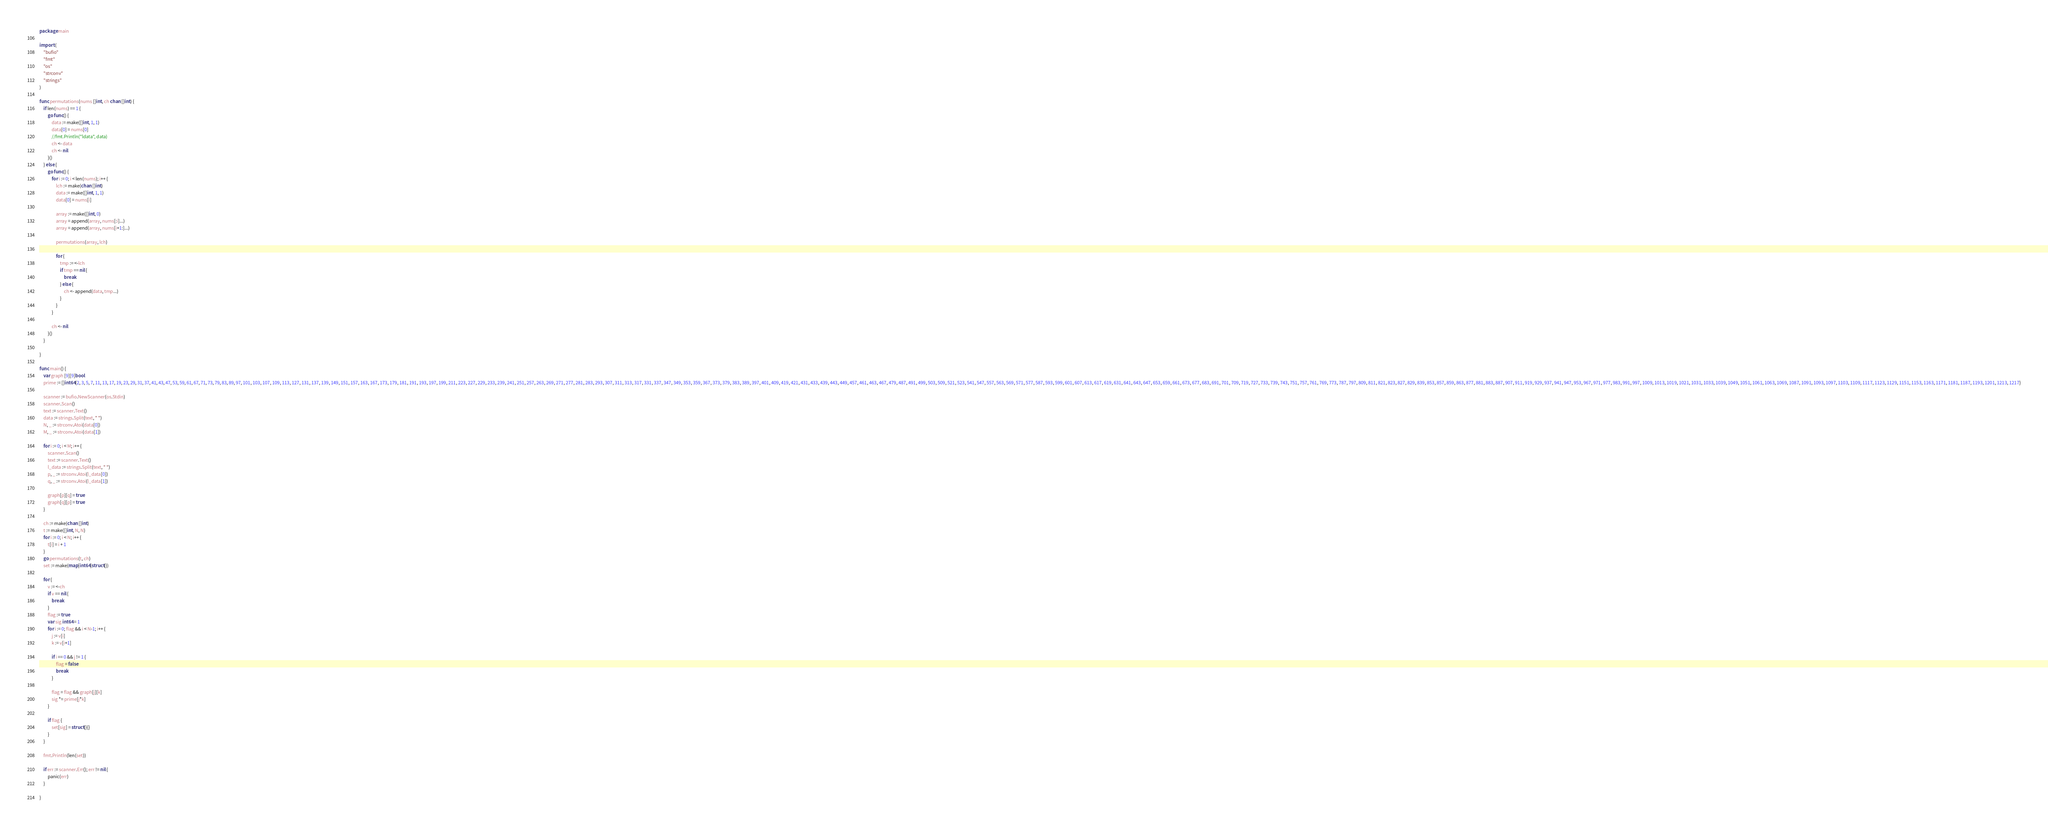<code> <loc_0><loc_0><loc_500><loc_500><_Go_>package main

import (
	"bufio"
	"fmt"
	"os"
	"strconv"
	"strings"
)

func permutations(nums []int, ch chan []int) {
	if len(nums) == 1 {
		go func() {
			data := make([]int, 1, 1)
			data[0] = nums[0]
			//fmt.Println("ldata", data)
			ch <- data
			ch <- nil
		}()
	} else {
		go func() {
			for i := 0; i < len(nums); i++ {
				lch := make(chan []int)
				data := make([]int, 1, 1)
				data[0] = nums[i]

				array := make([]int, 0)
				array = append(array, nums[:i]...)
				array = append(array, nums[i+1:]...)

				permutations(array, lch)

				for {
					tmp := <-lch
					if tmp == nil {
						break
					} else {
						ch <- append(data, tmp...)
					}
				}
			}

			ch <- nil
		}()
	}

}

func main() {
	var graph [9][9]bool
	prime := []int64{2, 3, 5, 7, 11, 13, 17, 19, 23, 29, 31, 37, 41, 43, 47, 53, 59, 61, 67, 71, 73, 79, 83, 89, 97, 101, 103, 107, 109, 113, 127, 131, 137, 139, 149, 151, 157, 163, 167, 173, 179, 181, 191, 193, 197, 199, 211, 223, 227, 229, 233, 239, 241, 251, 257, 263, 269, 271, 277, 281, 283, 293, 307, 311, 313, 317, 331, 337, 347, 349, 353, 359, 367, 373, 379, 383, 389, 397, 401, 409, 419, 421, 431, 433, 439, 443, 449, 457, 461, 463, 467, 479, 487, 491, 499, 503, 509, 521, 523, 541, 547, 557, 563, 569, 571, 577, 587, 593, 599, 601, 607, 613, 617, 619, 631, 641, 643, 647, 653, 659, 661, 673, 677, 683, 691, 701, 709, 719, 727, 733, 739, 743, 751, 757, 761, 769, 773, 787, 797, 809, 811, 821, 823, 827, 829, 839, 853, 857, 859, 863, 877, 881, 883, 887, 907, 911, 919, 929, 937, 941, 947, 953, 967, 971, 977, 983, 991, 997, 1009, 1013, 1019, 1021, 1031, 1033, 1039, 1049, 1051, 1061, 1063, 1069, 1087, 1091, 1093, 1097, 1103, 1109, 1117, 1123, 1129, 1151, 1153, 1163, 1171, 1181, 1187, 1193, 1201, 1213, 1217}

	scanner := bufio.NewScanner(os.Stdin)
	scanner.Scan()
	text := scanner.Text()
	data := strings.Split(text, " ")
	N, _ := strconv.Atoi(data[0])
	M, _ := strconv.Atoi(data[1])

	for i := 0; i < M; i++ {
		scanner.Scan()
		text := scanner.Text()
		l_data := strings.Split(text, " ")
		p, _ := strconv.Atoi(l_data[0])
		q, _ := strconv.Atoi(l_data[1])

		graph[p][q] = true
		graph[q][p] = true
	}

	ch := make(chan []int)
	t := make([]int, N, N)
	for i := 0; i < N; i++ {
		t[i] = i + 1
	}
	go permutations(t, ch)
	set := make(map[int64]struct{})

	for {
		v := <-ch
		if v == nil {
			break
		}
		flag := true
		var sig int64 = 1
		for i := 0; flag && i < N-1; i++ {
			j := v[i]
			k := v[i+1]

			if i == 0 && j != 1 {
				flag = false
				break
			}

			flag = flag && graph[j][k]
			sig *= prime[j*k]
		}

		if flag {
			set[sig] = struct{}{}
		}
	}

	fmt.Println(len(set))

	if err := scanner.Err(); err != nil {
		panic(err)
	}

}
</code> 